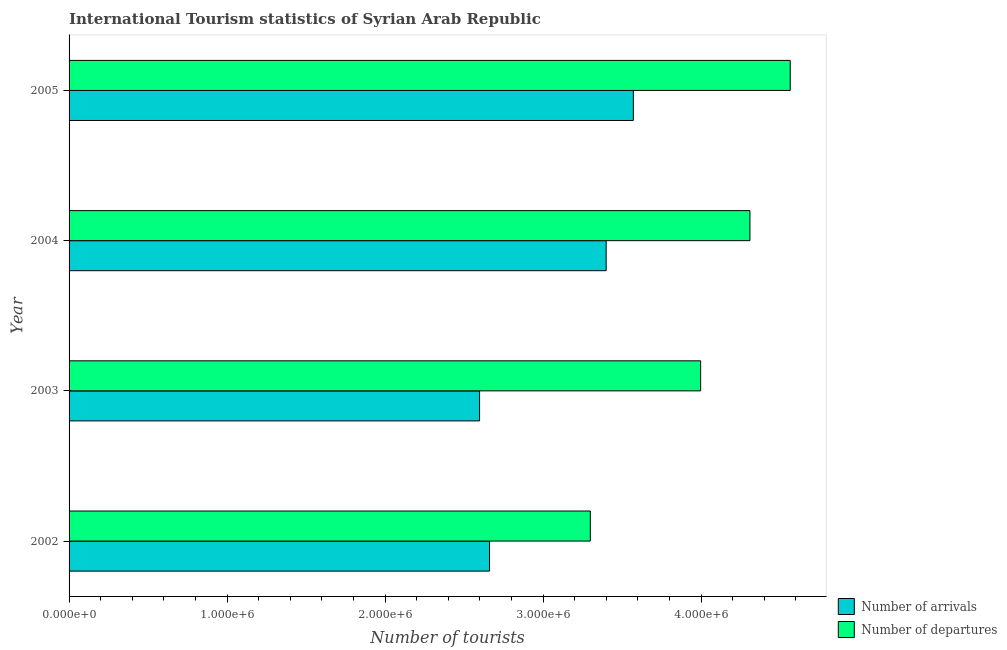Are the number of bars on each tick of the Y-axis equal?
Ensure brevity in your answer.  Yes. How many bars are there on the 1st tick from the top?
Provide a short and direct response. 2. In how many cases, is the number of bars for a given year not equal to the number of legend labels?
Your response must be concise. 0. What is the number of tourist departures in 2004?
Offer a very short reply. 4.31e+06. Across all years, what is the maximum number of tourist arrivals?
Provide a succinct answer. 3.57e+06. Across all years, what is the minimum number of tourist arrivals?
Your response must be concise. 2.60e+06. In which year was the number of tourist departures maximum?
Your answer should be compact. 2005. In which year was the number of tourist arrivals minimum?
Keep it short and to the point. 2003. What is the total number of tourist departures in the graph?
Offer a terse response. 1.62e+07. What is the difference between the number of tourist departures in 2002 and that in 2005?
Give a very brief answer. -1.26e+06. What is the difference between the number of tourist arrivals in 2005 and the number of tourist departures in 2003?
Keep it short and to the point. -4.26e+05. What is the average number of tourist departures per year?
Your answer should be very brief. 4.04e+06. In the year 2005, what is the difference between the number of tourist arrivals and number of tourist departures?
Give a very brief answer. -9.93e+05. What is the ratio of the number of tourist arrivals in 2002 to that in 2005?
Provide a short and direct response. 0.74. What is the difference between the highest and the second highest number of tourist arrivals?
Your answer should be very brief. 1.72e+05. What is the difference between the highest and the lowest number of tourist departures?
Your response must be concise. 1.26e+06. In how many years, is the number of tourist arrivals greater than the average number of tourist arrivals taken over all years?
Offer a very short reply. 2. Is the sum of the number of tourist departures in 2002 and 2003 greater than the maximum number of tourist arrivals across all years?
Your response must be concise. Yes. What does the 1st bar from the top in 2004 represents?
Your response must be concise. Number of departures. What does the 1st bar from the bottom in 2002 represents?
Provide a short and direct response. Number of arrivals. How many bars are there?
Your response must be concise. 8. Are all the bars in the graph horizontal?
Provide a short and direct response. Yes. How many years are there in the graph?
Make the answer very short. 4. What is the difference between two consecutive major ticks on the X-axis?
Offer a very short reply. 1.00e+06. Does the graph contain any zero values?
Your response must be concise. No. Does the graph contain grids?
Keep it short and to the point. No. Where does the legend appear in the graph?
Ensure brevity in your answer.  Bottom right. How many legend labels are there?
Offer a terse response. 2. How are the legend labels stacked?
Provide a short and direct response. Vertical. What is the title of the graph?
Make the answer very short. International Tourism statistics of Syrian Arab Republic. What is the label or title of the X-axis?
Your answer should be very brief. Number of tourists. What is the Number of tourists of Number of arrivals in 2002?
Offer a terse response. 2.66e+06. What is the Number of tourists of Number of departures in 2002?
Make the answer very short. 3.30e+06. What is the Number of tourists in Number of arrivals in 2003?
Offer a terse response. 2.60e+06. What is the Number of tourists of Number of departures in 2003?
Provide a succinct answer. 4.00e+06. What is the Number of tourists of Number of arrivals in 2004?
Keep it short and to the point. 3.40e+06. What is the Number of tourists of Number of departures in 2004?
Your response must be concise. 4.31e+06. What is the Number of tourists in Number of arrivals in 2005?
Offer a very short reply. 3.57e+06. What is the Number of tourists in Number of departures in 2005?
Provide a succinct answer. 4.56e+06. Across all years, what is the maximum Number of tourists in Number of arrivals?
Your answer should be compact. 3.57e+06. Across all years, what is the maximum Number of tourists of Number of departures?
Make the answer very short. 4.56e+06. Across all years, what is the minimum Number of tourists in Number of arrivals?
Offer a very short reply. 2.60e+06. Across all years, what is the minimum Number of tourists in Number of departures?
Provide a short and direct response. 3.30e+06. What is the total Number of tourists of Number of arrivals in the graph?
Provide a short and direct response. 1.22e+07. What is the total Number of tourists in Number of departures in the graph?
Provide a succinct answer. 1.62e+07. What is the difference between the Number of tourists of Number of arrivals in 2002 and that in 2003?
Your answer should be very brief. 6.30e+04. What is the difference between the Number of tourists in Number of departures in 2002 and that in 2003?
Provide a succinct answer. -6.98e+05. What is the difference between the Number of tourists in Number of arrivals in 2002 and that in 2004?
Your response must be concise. -7.38e+05. What is the difference between the Number of tourists of Number of departures in 2002 and that in 2004?
Offer a very short reply. -1.01e+06. What is the difference between the Number of tourists in Number of arrivals in 2002 and that in 2005?
Provide a succinct answer. -9.10e+05. What is the difference between the Number of tourists of Number of departures in 2002 and that in 2005?
Keep it short and to the point. -1.26e+06. What is the difference between the Number of tourists of Number of arrivals in 2003 and that in 2004?
Keep it short and to the point. -8.01e+05. What is the difference between the Number of tourists of Number of departures in 2003 and that in 2004?
Make the answer very short. -3.12e+05. What is the difference between the Number of tourists in Number of arrivals in 2003 and that in 2005?
Keep it short and to the point. -9.73e+05. What is the difference between the Number of tourists in Number of departures in 2003 and that in 2005?
Provide a short and direct response. -5.67e+05. What is the difference between the Number of tourists in Number of arrivals in 2004 and that in 2005?
Your response must be concise. -1.72e+05. What is the difference between the Number of tourists in Number of departures in 2004 and that in 2005?
Ensure brevity in your answer.  -2.55e+05. What is the difference between the Number of tourists of Number of arrivals in 2002 and the Number of tourists of Number of departures in 2003?
Offer a very short reply. -1.34e+06. What is the difference between the Number of tourists of Number of arrivals in 2002 and the Number of tourists of Number of departures in 2004?
Your answer should be compact. -1.65e+06. What is the difference between the Number of tourists in Number of arrivals in 2002 and the Number of tourists in Number of departures in 2005?
Offer a very short reply. -1.90e+06. What is the difference between the Number of tourists in Number of arrivals in 2003 and the Number of tourists in Number of departures in 2004?
Give a very brief answer. -1.71e+06. What is the difference between the Number of tourists of Number of arrivals in 2003 and the Number of tourists of Number of departures in 2005?
Provide a short and direct response. -1.97e+06. What is the difference between the Number of tourists in Number of arrivals in 2004 and the Number of tourists in Number of departures in 2005?
Give a very brief answer. -1.16e+06. What is the average Number of tourists of Number of arrivals per year?
Your response must be concise. 3.06e+06. What is the average Number of tourists in Number of departures per year?
Offer a very short reply. 4.04e+06. In the year 2002, what is the difference between the Number of tourists of Number of arrivals and Number of tourists of Number of departures?
Your answer should be very brief. -6.38e+05. In the year 2003, what is the difference between the Number of tourists in Number of arrivals and Number of tourists in Number of departures?
Provide a succinct answer. -1.40e+06. In the year 2004, what is the difference between the Number of tourists in Number of arrivals and Number of tourists in Number of departures?
Your answer should be compact. -9.10e+05. In the year 2005, what is the difference between the Number of tourists of Number of arrivals and Number of tourists of Number of departures?
Your answer should be compact. -9.93e+05. What is the ratio of the Number of tourists in Number of arrivals in 2002 to that in 2003?
Provide a short and direct response. 1.02. What is the ratio of the Number of tourists in Number of departures in 2002 to that in 2003?
Provide a succinct answer. 0.83. What is the ratio of the Number of tourists in Number of arrivals in 2002 to that in 2004?
Give a very brief answer. 0.78. What is the ratio of the Number of tourists in Number of departures in 2002 to that in 2004?
Provide a succinct answer. 0.77. What is the ratio of the Number of tourists in Number of arrivals in 2002 to that in 2005?
Your response must be concise. 0.75. What is the ratio of the Number of tourists in Number of departures in 2002 to that in 2005?
Provide a succinct answer. 0.72. What is the ratio of the Number of tourists of Number of arrivals in 2003 to that in 2004?
Give a very brief answer. 0.76. What is the ratio of the Number of tourists in Number of departures in 2003 to that in 2004?
Your answer should be compact. 0.93. What is the ratio of the Number of tourists of Number of arrivals in 2003 to that in 2005?
Give a very brief answer. 0.73. What is the ratio of the Number of tourists in Number of departures in 2003 to that in 2005?
Offer a terse response. 0.88. What is the ratio of the Number of tourists in Number of arrivals in 2004 to that in 2005?
Ensure brevity in your answer.  0.95. What is the ratio of the Number of tourists of Number of departures in 2004 to that in 2005?
Make the answer very short. 0.94. What is the difference between the highest and the second highest Number of tourists in Number of arrivals?
Your response must be concise. 1.72e+05. What is the difference between the highest and the second highest Number of tourists in Number of departures?
Your answer should be compact. 2.55e+05. What is the difference between the highest and the lowest Number of tourists in Number of arrivals?
Give a very brief answer. 9.73e+05. What is the difference between the highest and the lowest Number of tourists of Number of departures?
Offer a very short reply. 1.26e+06. 